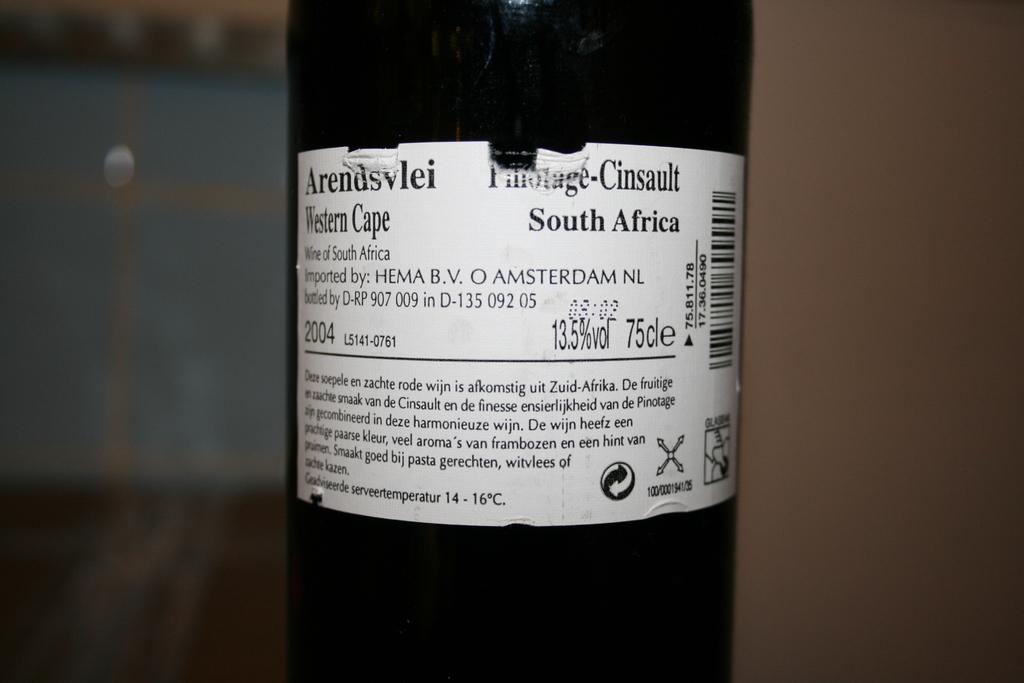What country does this wine come from?
Ensure brevity in your answer.  South africa. Is this a bottle of wine ?
Your answer should be compact. Yes. 